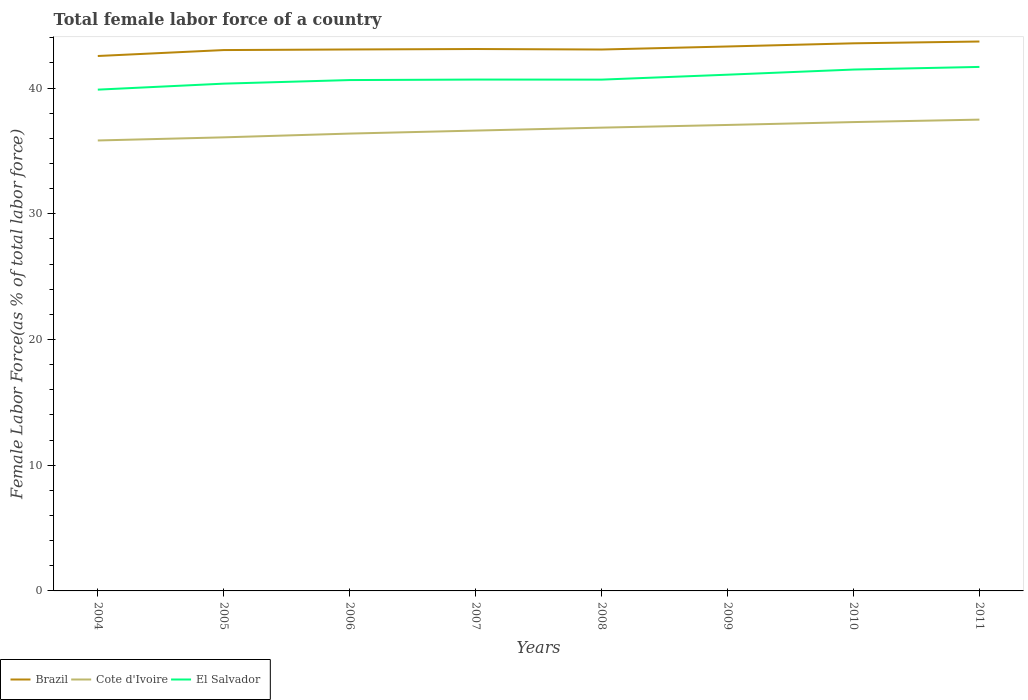How many different coloured lines are there?
Give a very brief answer. 3. Is the number of lines equal to the number of legend labels?
Keep it short and to the point. Yes. Across all years, what is the maximum percentage of female labor force in El Salvador?
Provide a short and direct response. 39.87. In which year was the percentage of female labor force in Cote d'Ivoire maximum?
Keep it short and to the point. 2004. What is the total percentage of female labor force in Cote d'Ivoire in the graph?
Keep it short and to the point. -0.24. What is the difference between the highest and the second highest percentage of female labor force in El Salvador?
Keep it short and to the point. 1.81. Is the percentage of female labor force in Brazil strictly greater than the percentage of female labor force in Cote d'Ivoire over the years?
Provide a succinct answer. No. How many lines are there?
Keep it short and to the point. 3. How many years are there in the graph?
Provide a short and direct response. 8. What is the difference between two consecutive major ticks on the Y-axis?
Provide a short and direct response. 10. Are the values on the major ticks of Y-axis written in scientific E-notation?
Your response must be concise. No. Does the graph contain grids?
Provide a short and direct response. No. Where does the legend appear in the graph?
Keep it short and to the point. Bottom left. What is the title of the graph?
Provide a short and direct response. Total female labor force of a country. Does "Congo (Democratic)" appear as one of the legend labels in the graph?
Provide a succinct answer. No. What is the label or title of the X-axis?
Offer a very short reply. Years. What is the label or title of the Y-axis?
Your answer should be compact. Female Labor Force(as % of total labor force). What is the Female Labor Force(as % of total labor force) in Brazil in 2004?
Your answer should be compact. 42.55. What is the Female Labor Force(as % of total labor force) in Cote d'Ivoire in 2004?
Give a very brief answer. 35.83. What is the Female Labor Force(as % of total labor force) of El Salvador in 2004?
Make the answer very short. 39.87. What is the Female Labor Force(as % of total labor force) in Brazil in 2005?
Offer a very short reply. 43.02. What is the Female Labor Force(as % of total labor force) in Cote d'Ivoire in 2005?
Your answer should be very brief. 36.08. What is the Female Labor Force(as % of total labor force) in El Salvador in 2005?
Offer a very short reply. 40.35. What is the Female Labor Force(as % of total labor force) of Brazil in 2006?
Your answer should be very brief. 43.07. What is the Female Labor Force(as % of total labor force) of Cote d'Ivoire in 2006?
Your answer should be compact. 36.38. What is the Female Labor Force(as % of total labor force) in El Salvador in 2006?
Your answer should be compact. 40.63. What is the Female Labor Force(as % of total labor force) of Brazil in 2007?
Your response must be concise. 43.1. What is the Female Labor Force(as % of total labor force) in Cote d'Ivoire in 2007?
Provide a succinct answer. 36.61. What is the Female Labor Force(as % of total labor force) of El Salvador in 2007?
Provide a short and direct response. 40.67. What is the Female Labor Force(as % of total labor force) of Brazil in 2008?
Your response must be concise. 43.06. What is the Female Labor Force(as % of total labor force) of Cote d'Ivoire in 2008?
Provide a short and direct response. 36.85. What is the Female Labor Force(as % of total labor force) in El Salvador in 2008?
Offer a very short reply. 40.67. What is the Female Labor Force(as % of total labor force) of Brazil in 2009?
Offer a very short reply. 43.3. What is the Female Labor Force(as % of total labor force) in Cote d'Ivoire in 2009?
Make the answer very short. 37.06. What is the Female Labor Force(as % of total labor force) in El Salvador in 2009?
Your response must be concise. 41.06. What is the Female Labor Force(as % of total labor force) of Brazil in 2010?
Ensure brevity in your answer.  43.56. What is the Female Labor Force(as % of total labor force) of Cote d'Ivoire in 2010?
Provide a short and direct response. 37.29. What is the Female Labor Force(as % of total labor force) in El Salvador in 2010?
Offer a very short reply. 41.47. What is the Female Labor Force(as % of total labor force) of Brazil in 2011?
Provide a succinct answer. 43.7. What is the Female Labor Force(as % of total labor force) in Cote d'Ivoire in 2011?
Ensure brevity in your answer.  37.49. What is the Female Labor Force(as % of total labor force) in El Salvador in 2011?
Offer a terse response. 41.68. Across all years, what is the maximum Female Labor Force(as % of total labor force) of Brazil?
Ensure brevity in your answer.  43.7. Across all years, what is the maximum Female Labor Force(as % of total labor force) in Cote d'Ivoire?
Make the answer very short. 37.49. Across all years, what is the maximum Female Labor Force(as % of total labor force) of El Salvador?
Your response must be concise. 41.68. Across all years, what is the minimum Female Labor Force(as % of total labor force) in Brazil?
Provide a succinct answer. 42.55. Across all years, what is the minimum Female Labor Force(as % of total labor force) of Cote d'Ivoire?
Keep it short and to the point. 35.83. Across all years, what is the minimum Female Labor Force(as % of total labor force) of El Salvador?
Offer a very short reply. 39.87. What is the total Female Labor Force(as % of total labor force) of Brazil in the graph?
Your answer should be very brief. 345.35. What is the total Female Labor Force(as % of total labor force) in Cote d'Ivoire in the graph?
Keep it short and to the point. 293.58. What is the total Female Labor Force(as % of total labor force) in El Salvador in the graph?
Offer a terse response. 326.4. What is the difference between the Female Labor Force(as % of total labor force) in Brazil in 2004 and that in 2005?
Your answer should be compact. -0.47. What is the difference between the Female Labor Force(as % of total labor force) in Cote d'Ivoire in 2004 and that in 2005?
Your response must be concise. -0.25. What is the difference between the Female Labor Force(as % of total labor force) of El Salvador in 2004 and that in 2005?
Give a very brief answer. -0.48. What is the difference between the Female Labor Force(as % of total labor force) in Brazil in 2004 and that in 2006?
Provide a succinct answer. -0.52. What is the difference between the Female Labor Force(as % of total labor force) of Cote d'Ivoire in 2004 and that in 2006?
Provide a succinct answer. -0.55. What is the difference between the Female Labor Force(as % of total labor force) of El Salvador in 2004 and that in 2006?
Your answer should be compact. -0.76. What is the difference between the Female Labor Force(as % of total labor force) of Brazil in 2004 and that in 2007?
Your answer should be very brief. -0.56. What is the difference between the Female Labor Force(as % of total labor force) of Cote d'Ivoire in 2004 and that in 2007?
Provide a succinct answer. -0.79. What is the difference between the Female Labor Force(as % of total labor force) of El Salvador in 2004 and that in 2007?
Your answer should be very brief. -0.8. What is the difference between the Female Labor Force(as % of total labor force) in Brazil in 2004 and that in 2008?
Offer a very short reply. -0.52. What is the difference between the Female Labor Force(as % of total labor force) of Cote d'Ivoire in 2004 and that in 2008?
Offer a terse response. -1.02. What is the difference between the Female Labor Force(as % of total labor force) of El Salvador in 2004 and that in 2008?
Give a very brief answer. -0.8. What is the difference between the Female Labor Force(as % of total labor force) in Brazil in 2004 and that in 2009?
Keep it short and to the point. -0.76. What is the difference between the Female Labor Force(as % of total labor force) of Cote d'Ivoire in 2004 and that in 2009?
Your answer should be compact. -1.23. What is the difference between the Female Labor Force(as % of total labor force) in El Salvador in 2004 and that in 2009?
Provide a short and direct response. -1.19. What is the difference between the Female Labor Force(as % of total labor force) of Brazil in 2004 and that in 2010?
Offer a terse response. -1.01. What is the difference between the Female Labor Force(as % of total labor force) of Cote d'Ivoire in 2004 and that in 2010?
Ensure brevity in your answer.  -1.46. What is the difference between the Female Labor Force(as % of total labor force) of El Salvador in 2004 and that in 2010?
Give a very brief answer. -1.6. What is the difference between the Female Labor Force(as % of total labor force) in Brazil in 2004 and that in 2011?
Offer a terse response. -1.15. What is the difference between the Female Labor Force(as % of total labor force) of Cote d'Ivoire in 2004 and that in 2011?
Provide a short and direct response. -1.66. What is the difference between the Female Labor Force(as % of total labor force) in El Salvador in 2004 and that in 2011?
Provide a succinct answer. -1.81. What is the difference between the Female Labor Force(as % of total labor force) of Brazil in 2005 and that in 2006?
Offer a very short reply. -0.05. What is the difference between the Female Labor Force(as % of total labor force) in Cote d'Ivoire in 2005 and that in 2006?
Keep it short and to the point. -0.3. What is the difference between the Female Labor Force(as % of total labor force) in El Salvador in 2005 and that in 2006?
Provide a short and direct response. -0.29. What is the difference between the Female Labor Force(as % of total labor force) in Brazil in 2005 and that in 2007?
Ensure brevity in your answer.  -0.08. What is the difference between the Female Labor Force(as % of total labor force) in Cote d'Ivoire in 2005 and that in 2007?
Make the answer very short. -0.54. What is the difference between the Female Labor Force(as % of total labor force) of El Salvador in 2005 and that in 2007?
Keep it short and to the point. -0.32. What is the difference between the Female Labor Force(as % of total labor force) of Brazil in 2005 and that in 2008?
Provide a short and direct response. -0.04. What is the difference between the Female Labor Force(as % of total labor force) of Cote d'Ivoire in 2005 and that in 2008?
Your response must be concise. -0.77. What is the difference between the Female Labor Force(as % of total labor force) in El Salvador in 2005 and that in 2008?
Provide a short and direct response. -0.32. What is the difference between the Female Labor Force(as % of total labor force) in Brazil in 2005 and that in 2009?
Offer a terse response. -0.28. What is the difference between the Female Labor Force(as % of total labor force) of Cote d'Ivoire in 2005 and that in 2009?
Give a very brief answer. -0.99. What is the difference between the Female Labor Force(as % of total labor force) in El Salvador in 2005 and that in 2009?
Your answer should be compact. -0.71. What is the difference between the Female Labor Force(as % of total labor force) in Brazil in 2005 and that in 2010?
Your response must be concise. -0.54. What is the difference between the Female Labor Force(as % of total labor force) of Cote d'Ivoire in 2005 and that in 2010?
Offer a very short reply. -1.21. What is the difference between the Female Labor Force(as % of total labor force) of El Salvador in 2005 and that in 2010?
Offer a terse response. -1.12. What is the difference between the Female Labor Force(as % of total labor force) of Brazil in 2005 and that in 2011?
Your answer should be compact. -0.68. What is the difference between the Female Labor Force(as % of total labor force) of Cote d'Ivoire in 2005 and that in 2011?
Your answer should be compact. -1.41. What is the difference between the Female Labor Force(as % of total labor force) of El Salvador in 2005 and that in 2011?
Ensure brevity in your answer.  -1.33. What is the difference between the Female Labor Force(as % of total labor force) in Brazil in 2006 and that in 2007?
Your answer should be compact. -0.04. What is the difference between the Female Labor Force(as % of total labor force) of Cote d'Ivoire in 2006 and that in 2007?
Give a very brief answer. -0.24. What is the difference between the Female Labor Force(as % of total labor force) in El Salvador in 2006 and that in 2007?
Your response must be concise. -0.04. What is the difference between the Female Labor Force(as % of total labor force) in Brazil in 2006 and that in 2008?
Make the answer very short. 0. What is the difference between the Female Labor Force(as % of total labor force) of Cote d'Ivoire in 2006 and that in 2008?
Ensure brevity in your answer.  -0.47. What is the difference between the Female Labor Force(as % of total labor force) in El Salvador in 2006 and that in 2008?
Provide a short and direct response. -0.04. What is the difference between the Female Labor Force(as % of total labor force) of Brazil in 2006 and that in 2009?
Your answer should be compact. -0.24. What is the difference between the Female Labor Force(as % of total labor force) in Cote d'Ivoire in 2006 and that in 2009?
Your answer should be compact. -0.69. What is the difference between the Female Labor Force(as % of total labor force) of El Salvador in 2006 and that in 2009?
Your response must be concise. -0.43. What is the difference between the Female Labor Force(as % of total labor force) of Brazil in 2006 and that in 2010?
Give a very brief answer. -0.49. What is the difference between the Female Labor Force(as % of total labor force) in Cote d'Ivoire in 2006 and that in 2010?
Make the answer very short. -0.91. What is the difference between the Female Labor Force(as % of total labor force) of El Salvador in 2006 and that in 2010?
Keep it short and to the point. -0.84. What is the difference between the Female Labor Force(as % of total labor force) in Brazil in 2006 and that in 2011?
Provide a short and direct response. -0.63. What is the difference between the Female Labor Force(as % of total labor force) of Cote d'Ivoire in 2006 and that in 2011?
Provide a short and direct response. -1.11. What is the difference between the Female Labor Force(as % of total labor force) of El Salvador in 2006 and that in 2011?
Your answer should be compact. -1.05. What is the difference between the Female Labor Force(as % of total labor force) in Brazil in 2007 and that in 2008?
Make the answer very short. 0.04. What is the difference between the Female Labor Force(as % of total labor force) in Cote d'Ivoire in 2007 and that in 2008?
Your answer should be compact. -0.23. What is the difference between the Female Labor Force(as % of total labor force) of El Salvador in 2007 and that in 2008?
Make the answer very short. 0. What is the difference between the Female Labor Force(as % of total labor force) of Brazil in 2007 and that in 2009?
Your answer should be compact. -0.2. What is the difference between the Female Labor Force(as % of total labor force) of Cote d'Ivoire in 2007 and that in 2009?
Keep it short and to the point. -0.45. What is the difference between the Female Labor Force(as % of total labor force) in El Salvador in 2007 and that in 2009?
Give a very brief answer. -0.39. What is the difference between the Female Labor Force(as % of total labor force) of Brazil in 2007 and that in 2010?
Offer a terse response. -0.45. What is the difference between the Female Labor Force(as % of total labor force) in Cote d'Ivoire in 2007 and that in 2010?
Provide a succinct answer. -0.68. What is the difference between the Female Labor Force(as % of total labor force) in El Salvador in 2007 and that in 2010?
Make the answer very short. -0.8. What is the difference between the Female Labor Force(as % of total labor force) in Brazil in 2007 and that in 2011?
Provide a short and direct response. -0.6. What is the difference between the Female Labor Force(as % of total labor force) of Cote d'Ivoire in 2007 and that in 2011?
Provide a short and direct response. -0.87. What is the difference between the Female Labor Force(as % of total labor force) of El Salvador in 2007 and that in 2011?
Give a very brief answer. -1.01. What is the difference between the Female Labor Force(as % of total labor force) of Brazil in 2008 and that in 2009?
Keep it short and to the point. -0.24. What is the difference between the Female Labor Force(as % of total labor force) in Cote d'Ivoire in 2008 and that in 2009?
Ensure brevity in your answer.  -0.21. What is the difference between the Female Labor Force(as % of total labor force) in El Salvador in 2008 and that in 2009?
Provide a succinct answer. -0.39. What is the difference between the Female Labor Force(as % of total labor force) in Brazil in 2008 and that in 2010?
Provide a short and direct response. -0.49. What is the difference between the Female Labor Force(as % of total labor force) in Cote d'Ivoire in 2008 and that in 2010?
Keep it short and to the point. -0.44. What is the difference between the Female Labor Force(as % of total labor force) of El Salvador in 2008 and that in 2010?
Keep it short and to the point. -0.8. What is the difference between the Female Labor Force(as % of total labor force) in Brazil in 2008 and that in 2011?
Ensure brevity in your answer.  -0.64. What is the difference between the Female Labor Force(as % of total labor force) of Cote d'Ivoire in 2008 and that in 2011?
Your response must be concise. -0.64. What is the difference between the Female Labor Force(as % of total labor force) of El Salvador in 2008 and that in 2011?
Give a very brief answer. -1.01. What is the difference between the Female Labor Force(as % of total labor force) of Brazil in 2009 and that in 2010?
Ensure brevity in your answer.  -0.25. What is the difference between the Female Labor Force(as % of total labor force) in Cote d'Ivoire in 2009 and that in 2010?
Provide a succinct answer. -0.23. What is the difference between the Female Labor Force(as % of total labor force) in El Salvador in 2009 and that in 2010?
Your answer should be very brief. -0.41. What is the difference between the Female Labor Force(as % of total labor force) of Brazil in 2009 and that in 2011?
Provide a succinct answer. -0.39. What is the difference between the Female Labor Force(as % of total labor force) in Cote d'Ivoire in 2009 and that in 2011?
Provide a succinct answer. -0.42. What is the difference between the Female Labor Force(as % of total labor force) in El Salvador in 2009 and that in 2011?
Keep it short and to the point. -0.62. What is the difference between the Female Labor Force(as % of total labor force) of Brazil in 2010 and that in 2011?
Provide a succinct answer. -0.14. What is the difference between the Female Labor Force(as % of total labor force) in Cote d'Ivoire in 2010 and that in 2011?
Provide a short and direct response. -0.2. What is the difference between the Female Labor Force(as % of total labor force) of El Salvador in 2010 and that in 2011?
Ensure brevity in your answer.  -0.21. What is the difference between the Female Labor Force(as % of total labor force) of Brazil in 2004 and the Female Labor Force(as % of total labor force) of Cote d'Ivoire in 2005?
Your answer should be compact. 6.47. What is the difference between the Female Labor Force(as % of total labor force) in Brazil in 2004 and the Female Labor Force(as % of total labor force) in El Salvador in 2005?
Provide a short and direct response. 2.2. What is the difference between the Female Labor Force(as % of total labor force) in Cote d'Ivoire in 2004 and the Female Labor Force(as % of total labor force) in El Salvador in 2005?
Offer a very short reply. -4.52. What is the difference between the Female Labor Force(as % of total labor force) of Brazil in 2004 and the Female Labor Force(as % of total labor force) of Cote d'Ivoire in 2006?
Give a very brief answer. 6.17. What is the difference between the Female Labor Force(as % of total labor force) of Brazil in 2004 and the Female Labor Force(as % of total labor force) of El Salvador in 2006?
Offer a very short reply. 1.91. What is the difference between the Female Labor Force(as % of total labor force) in Cote d'Ivoire in 2004 and the Female Labor Force(as % of total labor force) in El Salvador in 2006?
Your answer should be compact. -4.8. What is the difference between the Female Labor Force(as % of total labor force) of Brazil in 2004 and the Female Labor Force(as % of total labor force) of Cote d'Ivoire in 2007?
Ensure brevity in your answer.  5.93. What is the difference between the Female Labor Force(as % of total labor force) of Brazil in 2004 and the Female Labor Force(as % of total labor force) of El Salvador in 2007?
Your answer should be compact. 1.87. What is the difference between the Female Labor Force(as % of total labor force) in Cote d'Ivoire in 2004 and the Female Labor Force(as % of total labor force) in El Salvador in 2007?
Make the answer very short. -4.84. What is the difference between the Female Labor Force(as % of total labor force) of Brazil in 2004 and the Female Labor Force(as % of total labor force) of Cote d'Ivoire in 2008?
Provide a succinct answer. 5.7. What is the difference between the Female Labor Force(as % of total labor force) of Brazil in 2004 and the Female Labor Force(as % of total labor force) of El Salvador in 2008?
Give a very brief answer. 1.88. What is the difference between the Female Labor Force(as % of total labor force) of Cote d'Ivoire in 2004 and the Female Labor Force(as % of total labor force) of El Salvador in 2008?
Offer a very short reply. -4.84. What is the difference between the Female Labor Force(as % of total labor force) of Brazil in 2004 and the Female Labor Force(as % of total labor force) of Cote d'Ivoire in 2009?
Your answer should be very brief. 5.48. What is the difference between the Female Labor Force(as % of total labor force) in Brazil in 2004 and the Female Labor Force(as % of total labor force) in El Salvador in 2009?
Your answer should be very brief. 1.49. What is the difference between the Female Labor Force(as % of total labor force) in Cote d'Ivoire in 2004 and the Female Labor Force(as % of total labor force) in El Salvador in 2009?
Keep it short and to the point. -5.23. What is the difference between the Female Labor Force(as % of total labor force) in Brazil in 2004 and the Female Labor Force(as % of total labor force) in Cote d'Ivoire in 2010?
Keep it short and to the point. 5.26. What is the difference between the Female Labor Force(as % of total labor force) in Brazil in 2004 and the Female Labor Force(as % of total labor force) in El Salvador in 2010?
Your answer should be compact. 1.08. What is the difference between the Female Labor Force(as % of total labor force) in Cote d'Ivoire in 2004 and the Female Labor Force(as % of total labor force) in El Salvador in 2010?
Make the answer very short. -5.64. What is the difference between the Female Labor Force(as % of total labor force) in Brazil in 2004 and the Female Labor Force(as % of total labor force) in Cote d'Ivoire in 2011?
Your response must be concise. 5.06. What is the difference between the Female Labor Force(as % of total labor force) of Brazil in 2004 and the Female Labor Force(as % of total labor force) of El Salvador in 2011?
Make the answer very short. 0.87. What is the difference between the Female Labor Force(as % of total labor force) in Cote d'Ivoire in 2004 and the Female Labor Force(as % of total labor force) in El Salvador in 2011?
Keep it short and to the point. -5.85. What is the difference between the Female Labor Force(as % of total labor force) in Brazil in 2005 and the Female Labor Force(as % of total labor force) in Cote d'Ivoire in 2006?
Keep it short and to the point. 6.64. What is the difference between the Female Labor Force(as % of total labor force) of Brazil in 2005 and the Female Labor Force(as % of total labor force) of El Salvador in 2006?
Offer a terse response. 2.39. What is the difference between the Female Labor Force(as % of total labor force) in Cote d'Ivoire in 2005 and the Female Labor Force(as % of total labor force) in El Salvador in 2006?
Give a very brief answer. -4.56. What is the difference between the Female Labor Force(as % of total labor force) in Brazil in 2005 and the Female Labor Force(as % of total labor force) in Cote d'Ivoire in 2007?
Offer a terse response. 6.4. What is the difference between the Female Labor Force(as % of total labor force) of Brazil in 2005 and the Female Labor Force(as % of total labor force) of El Salvador in 2007?
Ensure brevity in your answer.  2.35. What is the difference between the Female Labor Force(as % of total labor force) of Cote d'Ivoire in 2005 and the Female Labor Force(as % of total labor force) of El Salvador in 2007?
Provide a short and direct response. -4.6. What is the difference between the Female Labor Force(as % of total labor force) of Brazil in 2005 and the Female Labor Force(as % of total labor force) of Cote d'Ivoire in 2008?
Your answer should be compact. 6.17. What is the difference between the Female Labor Force(as % of total labor force) of Brazil in 2005 and the Female Labor Force(as % of total labor force) of El Salvador in 2008?
Make the answer very short. 2.35. What is the difference between the Female Labor Force(as % of total labor force) of Cote d'Ivoire in 2005 and the Female Labor Force(as % of total labor force) of El Salvador in 2008?
Give a very brief answer. -4.59. What is the difference between the Female Labor Force(as % of total labor force) in Brazil in 2005 and the Female Labor Force(as % of total labor force) in Cote d'Ivoire in 2009?
Offer a terse response. 5.96. What is the difference between the Female Labor Force(as % of total labor force) in Brazil in 2005 and the Female Labor Force(as % of total labor force) in El Salvador in 2009?
Make the answer very short. 1.96. What is the difference between the Female Labor Force(as % of total labor force) in Cote d'Ivoire in 2005 and the Female Labor Force(as % of total labor force) in El Salvador in 2009?
Your response must be concise. -4.98. What is the difference between the Female Labor Force(as % of total labor force) of Brazil in 2005 and the Female Labor Force(as % of total labor force) of Cote d'Ivoire in 2010?
Your answer should be compact. 5.73. What is the difference between the Female Labor Force(as % of total labor force) in Brazil in 2005 and the Female Labor Force(as % of total labor force) in El Salvador in 2010?
Provide a succinct answer. 1.55. What is the difference between the Female Labor Force(as % of total labor force) in Cote d'Ivoire in 2005 and the Female Labor Force(as % of total labor force) in El Salvador in 2010?
Keep it short and to the point. -5.39. What is the difference between the Female Labor Force(as % of total labor force) of Brazil in 2005 and the Female Labor Force(as % of total labor force) of Cote d'Ivoire in 2011?
Your answer should be very brief. 5.53. What is the difference between the Female Labor Force(as % of total labor force) of Brazil in 2005 and the Female Labor Force(as % of total labor force) of El Salvador in 2011?
Provide a short and direct response. 1.34. What is the difference between the Female Labor Force(as % of total labor force) in Cote d'Ivoire in 2005 and the Female Labor Force(as % of total labor force) in El Salvador in 2011?
Provide a short and direct response. -5.6. What is the difference between the Female Labor Force(as % of total labor force) in Brazil in 2006 and the Female Labor Force(as % of total labor force) in Cote d'Ivoire in 2007?
Your answer should be very brief. 6.45. What is the difference between the Female Labor Force(as % of total labor force) of Brazil in 2006 and the Female Labor Force(as % of total labor force) of El Salvador in 2007?
Your answer should be compact. 2.39. What is the difference between the Female Labor Force(as % of total labor force) in Cote d'Ivoire in 2006 and the Female Labor Force(as % of total labor force) in El Salvador in 2007?
Offer a very short reply. -4.3. What is the difference between the Female Labor Force(as % of total labor force) of Brazil in 2006 and the Female Labor Force(as % of total labor force) of Cote d'Ivoire in 2008?
Your response must be concise. 6.22. What is the difference between the Female Labor Force(as % of total labor force) in Brazil in 2006 and the Female Labor Force(as % of total labor force) in El Salvador in 2008?
Provide a short and direct response. 2.4. What is the difference between the Female Labor Force(as % of total labor force) of Cote d'Ivoire in 2006 and the Female Labor Force(as % of total labor force) of El Salvador in 2008?
Give a very brief answer. -4.29. What is the difference between the Female Labor Force(as % of total labor force) of Brazil in 2006 and the Female Labor Force(as % of total labor force) of Cote d'Ivoire in 2009?
Offer a very short reply. 6. What is the difference between the Female Labor Force(as % of total labor force) in Brazil in 2006 and the Female Labor Force(as % of total labor force) in El Salvador in 2009?
Your answer should be very brief. 2.01. What is the difference between the Female Labor Force(as % of total labor force) of Cote d'Ivoire in 2006 and the Female Labor Force(as % of total labor force) of El Salvador in 2009?
Keep it short and to the point. -4.68. What is the difference between the Female Labor Force(as % of total labor force) of Brazil in 2006 and the Female Labor Force(as % of total labor force) of Cote d'Ivoire in 2010?
Make the answer very short. 5.78. What is the difference between the Female Labor Force(as % of total labor force) of Brazil in 2006 and the Female Labor Force(as % of total labor force) of El Salvador in 2010?
Ensure brevity in your answer.  1.6. What is the difference between the Female Labor Force(as % of total labor force) of Cote d'Ivoire in 2006 and the Female Labor Force(as % of total labor force) of El Salvador in 2010?
Offer a very short reply. -5.09. What is the difference between the Female Labor Force(as % of total labor force) of Brazil in 2006 and the Female Labor Force(as % of total labor force) of Cote d'Ivoire in 2011?
Offer a terse response. 5.58. What is the difference between the Female Labor Force(as % of total labor force) of Brazil in 2006 and the Female Labor Force(as % of total labor force) of El Salvador in 2011?
Your answer should be compact. 1.39. What is the difference between the Female Labor Force(as % of total labor force) of Cote d'Ivoire in 2006 and the Female Labor Force(as % of total labor force) of El Salvador in 2011?
Make the answer very short. -5.3. What is the difference between the Female Labor Force(as % of total labor force) of Brazil in 2007 and the Female Labor Force(as % of total labor force) of Cote d'Ivoire in 2008?
Give a very brief answer. 6.25. What is the difference between the Female Labor Force(as % of total labor force) in Brazil in 2007 and the Female Labor Force(as % of total labor force) in El Salvador in 2008?
Make the answer very short. 2.43. What is the difference between the Female Labor Force(as % of total labor force) in Cote d'Ivoire in 2007 and the Female Labor Force(as % of total labor force) in El Salvador in 2008?
Ensure brevity in your answer.  -4.05. What is the difference between the Female Labor Force(as % of total labor force) in Brazil in 2007 and the Female Labor Force(as % of total labor force) in Cote d'Ivoire in 2009?
Your response must be concise. 6.04. What is the difference between the Female Labor Force(as % of total labor force) in Brazil in 2007 and the Female Labor Force(as % of total labor force) in El Salvador in 2009?
Offer a very short reply. 2.04. What is the difference between the Female Labor Force(as % of total labor force) of Cote d'Ivoire in 2007 and the Female Labor Force(as % of total labor force) of El Salvador in 2009?
Your response must be concise. -4.45. What is the difference between the Female Labor Force(as % of total labor force) in Brazil in 2007 and the Female Labor Force(as % of total labor force) in Cote d'Ivoire in 2010?
Offer a very short reply. 5.81. What is the difference between the Female Labor Force(as % of total labor force) in Brazil in 2007 and the Female Labor Force(as % of total labor force) in El Salvador in 2010?
Ensure brevity in your answer.  1.63. What is the difference between the Female Labor Force(as % of total labor force) in Cote d'Ivoire in 2007 and the Female Labor Force(as % of total labor force) in El Salvador in 2010?
Provide a short and direct response. -4.85. What is the difference between the Female Labor Force(as % of total labor force) in Brazil in 2007 and the Female Labor Force(as % of total labor force) in Cote d'Ivoire in 2011?
Offer a very short reply. 5.62. What is the difference between the Female Labor Force(as % of total labor force) in Brazil in 2007 and the Female Labor Force(as % of total labor force) in El Salvador in 2011?
Give a very brief answer. 1.42. What is the difference between the Female Labor Force(as % of total labor force) of Cote d'Ivoire in 2007 and the Female Labor Force(as % of total labor force) of El Salvador in 2011?
Make the answer very short. -5.06. What is the difference between the Female Labor Force(as % of total labor force) in Brazil in 2008 and the Female Labor Force(as % of total labor force) in Cote d'Ivoire in 2009?
Ensure brevity in your answer.  6. What is the difference between the Female Labor Force(as % of total labor force) in Brazil in 2008 and the Female Labor Force(as % of total labor force) in El Salvador in 2009?
Offer a very short reply. 2. What is the difference between the Female Labor Force(as % of total labor force) of Cote d'Ivoire in 2008 and the Female Labor Force(as % of total labor force) of El Salvador in 2009?
Your answer should be compact. -4.21. What is the difference between the Female Labor Force(as % of total labor force) of Brazil in 2008 and the Female Labor Force(as % of total labor force) of Cote d'Ivoire in 2010?
Ensure brevity in your answer.  5.77. What is the difference between the Female Labor Force(as % of total labor force) of Brazil in 2008 and the Female Labor Force(as % of total labor force) of El Salvador in 2010?
Keep it short and to the point. 1.59. What is the difference between the Female Labor Force(as % of total labor force) of Cote d'Ivoire in 2008 and the Female Labor Force(as % of total labor force) of El Salvador in 2010?
Provide a short and direct response. -4.62. What is the difference between the Female Labor Force(as % of total labor force) in Brazil in 2008 and the Female Labor Force(as % of total labor force) in Cote d'Ivoire in 2011?
Ensure brevity in your answer.  5.58. What is the difference between the Female Labor Force(as % of total labor force) in Brazil in 2008 and the Female Labor Force(as % of total labor force) in El Salvador in 2011?
Ensure brevity in your answer.  1.38. What is the difference between the Female Labor Force(as % of total labor force) of Cote d'Ivoire in 2008 and the Female Labor Force(as % of total labor force) of El Salvador in 2011?
Your response must be concise. -4.83. What is the difference between the Female Labor Force(as % of total labor force) in Brazil in 2009 and the Female Labor Force(as % of total labor force) in Cote d'Ivoire in 2010?
Your answer should be very brief. 6.01. What is the difference between the Female Labor Force(as % of total labor force) of Brazil in 2009 and the Female Labor Force(as % of total labor force) of El Salvador in 2010?
Your answer should be compact. 1.83. What is the difference between the Female Labor Force(as % of total labor force) of Cote d'Ivoire in 2009 and the Female Labor Force(as % of total labor force) of El Salvador in 2010?
Provide a succinct answer. -4.41. What is the difference between the Female Labor Force(as % of total labor force) of Brazil in 2009 and the Female Labor Force(as % of total labor force) of Cote d'Ivoire in 2011?
Make the answer very short. 5.82. What is the difference between the Female Labor Force(as % of total labor force) in Brazil in 2009 and the Female Labor Force(as % of total labor force) in El Salvador in 2011?
Ensure brevity in your answer.  1.63. What is the difference between the Female Labor Force(as % of total labor force) of Cote d'Ivoire in 2009 and the Female Labor Force(as % of total labor force) of El Salvador in 2011?
Give a very brief answer. -4.62. What is the difference between the Female Labor Force(as % of total labor force) in Brazil in 2010 and the Female Labor Force(as % of total labor force) in Cote d'Ivoire in 2011?
Offer a very short reply. 6.07. What is the difference between the Female Labor Force(as % of total labor force) in Brazil in 2010 and the Female Labor Force(as % of total labor force) in El Salvador in 2011?
Your answer should be very brief. 1.88. What is the difference between the Female Labor Force(as % of total labor force) in Cote d'Ivoire in 2010 and the Female Labor Force(as % of total labor force) in El Salvador in 2011?
Make the answer very short. -4.39. What is the average Female Labor Force(as % of total labor force) in Brazil per year?
Keep it short and to the point. 43.17. What is the average Female Labor Force(as % of total labor force) in Cote d'Ivoire per year?
Ensure brevity in your answer.  36.7. What is the average Female Labor Force(as % of total labor force) of El Salvador per year?
Ensure brevity in your answer.  40.8. In the year 2004, what is the difference between the Female Labor Force(as % of total labor force) in Brazil and Female Labor Force(as % of total labor force) in Cote d'Ivoire?
Provide a succinct answer. 6.72. In the year 2004, what is the difference between the Female Labor Force(as % of total labor force) of Brazil and Female Labor Force(as % of total labor force) of El Salvador?
Offer a very short reply. 2.68. In the year 2004, what is the difference between the Female Labor Force(as % of total labor force) of Cote d'Ivoire and Female Labor Force(as % of total labor force) of El Salvador?
Your answer should be compact. -4.04. In the year 2005, what is the difference between the Female Labor Force(as % of total labor force) in Brazil and Female Labor Force(as % of total labor force) in Cote d'Ivoire?
Your answer should be very brief. 6.94. In the year 2005, what is the difference between the Female Labor Force(as % of total labor force) of Brazil and Female Labor Force(as % of total labor force) of El Salvador?
Your response must be concise. 2.67. In the year 2005, what is the difference between the Female Labor Force(as % of total labor force) in Cote d'Ivoire and Female Labor Force(as % of total labor force) in El Salvador?
Make the answer very short. -4.27. In the year 2006, what is the difference between the Female Labor Force(as % of total labor force) in Brazil and Female Labor Force(as % of total labor force) in Cote d'Ivoire?
Offer a terse response. 6.69. In the year 2006, what is the difference between the Female Labor Force(as % of total labor force) of Brazil and Female Labor Force(as % of total labor force) of El Salvador?
Ensure brevity in your answer.  2.43. In the year 2006, what is the difference between the Female Labor Force(as % of total labor force) in Cote d'Ivoire and Female Labor Force(as % of total labor force) in El Salvador?
Offer a very short reply. -4.26. In the year 2007, what is the difference between the Female Labor Force(as % of total labor force) of Brazil and Female Labor Force(as % of total labor force) of Cote d'Ivoire?
Keep it short and to the point. 6.49. In the year 2007, what is the difference between the Female Labor Force(as % of total labor force) of Brazil and Female Labor Force(as % of total labor force) of El Salvador?
Provide a short and direct response. 2.43. In the year 2007, what is the difference between the Female Labor Force(as % of total labor force) of Cote d'Ivoire and Female Labor Force(as % of total labor force) of El Salvador?
Offer a very short reply. -4.06. In the year 2008, what is the difference between the Female Labor Force(as % of total labor force) of Brazil and Female Labor Force(as % of total labor force) of Cote d'Ivoire?
Give a very brief answer. 6.21. In the year 2008, what is the difference between the Female Labor Force(as % of total labor force) in Brazil and Female Labor Force(as % of total labor force) in El Salvador?
Keep it short and to the point. 2.39. In the year 2008, what is the difference between the Female Labor Force(as % of total labor force) of Cote d'Ivoire and Female Labor Force(as % of total labor force) of El Salvador?
Your answer should be compact. -3.82. In the year 2009, what is the difference between the Female Labor Force(as % of total labor force) in Brazil and Female Labor Force(as % of total labor force) in Cote d'Ivoire?
Give a very brief answer. 6.24. In the year 2009, what is the difference between the Female Labor Force(as % of total labor force) in Brazil and Female Labor Force(as % of total labor force) in El Salvador?
Offer a very short reply. 2.24. In the year 2009, what is the difference between the Female Labor Force(as % of total labor force) in Cote d'Ivoire and Female Labor Force(as % of total labor force) in El Salvador?
Your answer should be very brief. -4. In the year 2010, what is the difference between the Female Labor Force(as % of total labor force) of Brazil and Female Labor Force(as % of total labor force) of Cote d'Ivoire?
Your answer should be compact. 6.27. In the year 2010, what is the difference between the Female Labor Force(as % of total labor force) in Brazil and Female Labor Force(as % of total labor force) in El Salvador?
Provide a short and direct response. 2.09. In the year 2010, what is the difference between the Female Labor Force(as % of total labor force) of Cote d'Ivoire and Female Labor Force(as % of total labor force) of El Salvador?
Provide a succinct answer. -4.18. In the year 2011, what is the difference between the Female Labor Force(as % of total labor force) of Brazil and Female Labor Force(as % of total labor force) of Cote d'Ivoire?
Offer a very short reply. 6.21. In the year 2011, what is the difference between the Female Labor Force(as % of total labor force) in Brazil and Female Labor Force(as % of total labor force) in El Salvador?
Offer a terse response. 2.02. In the year 2011, what is the difference between the Female Labor Force(as % of total labor force) in Cote d'Ivoire and Female Labor Force(as % of total labor force) in El Salvador?
Offer a terse response. -4.19. What is the ratio of the Female Labor Force(as % of total labor force) of Brazil in 2004 to that in 2005?
Your answer should be very brief. 0.99. What is the ratio of the Female Labor Force(as % of total labor force) in Cote d'Ivoire in 2004 to that in 2005?
Offer a terse response. 0.99. What is the ratio of the Female Labor Force(as % of total labor force) of Brazil in 2004 to that in 2006?
Offer a terse response. 0.99. What is the ratio of the Female Labor Force(as % of total labor force) in Cote d'Ivoire in 2004 to that in 2006?
Offer a very short reply. 0.98. What is the ratio of the Female Labor Force(as % of total labor force) of El Salvador in 2004 to that in 2006?
Make the answer very short. 0.98. What is the ratio of the Female Labor Force(as % of total labor force) in Brazil in 2004 to that in 2007?
Offer a terse response. 0.99. What is the ratio of the Female Labor Force(as % of total labor force) of Cote d'Ivoire in 2004 to that in 2007?
Your answer should be very brief. 0.98. What is the ratio of the Female Labor Force(as % of total labor force) of El Salvador in 2004 to that in 2007?
Offer a very short reply. 0.98. What is the ratio of the Female Labor Force(as % of total labor force) of Brazil in 2004 to that in 2008?
Give a very brief answer. 0.99. What is the ratio of the Female Labor Force(as % of total labor force) of Cote d'Ivoire in 2004 to that in 2008?
Provide a short and direct response. 0.97. What is the ratio of the Female Labor Force(as % of total labor force) of El Salvador in 2004 to that in 2008?
Offer a terse response. 0.98. What is the ratio of the Female Labor Force(as % of total labor force) of Brazil in 2004 to that in 2009?
Your answer should be compact. 0.98. What is the ratio of the Female Labor Force(as % of total labor force) in Cote d'Ivoire in 2004 to that in 2009?
Provide a short and direct response. 0.97. What is the ratio of the Female Labor Force(as % of total labor force) in El Salvador in 2004 to that in 2009?
Your answer should be compact. 0.97. What is the ratio of the Female Labor Force(as % of total labor force) of Brazil in 2004 to that in 2010?
Give a very brief answer. 0.98. What is the ratio of the Female Labor Force(as % of total labor force) in Cote d'Ivoire in 2004 to that in 2010?
Offer a very short reply. 0.96. What is the ratio of the Female Labor Force(as % of total labor force) of El Salvador in 2004 to that in 2010?
Keep it short and to the point. 0.96. What is the ratio of the Female Labor Force(as % of total labor force) of Brazil in 2004 to that in 2011?
Your answer should be very brief. 0.97. What is the ratio of the Female Labor Force(as % of total labor force) in Cote d'Ivoire in 2004 to that in 2011?
Ensure brevity in your answer.  0.96. What is the ratio of the Female Labor Force(as % of total labor force) of El Salvador in 2004 to that in 2011?
Offer a very short reply. 0.96. What is the ratio of the Female Labor Force(as % of total labor force) of El Salvador in 2005 to that in 2006?
Provide a succinct answer. 0.99. What is the ratio of the Female Labor Force(as % of total labor force) in Brazil in 2005 to that in 2007?
Your response must be concise. 1. What is the ratio of the Female Labor Force(as % of total labor force) in El Salvador in 2005 to that in 2008?
Your answer should be very brief. 0.99. What is the ratio of the Female Labor Force(as % of total labor force) in Brazil in 2005 to that in 2009?
Ensure brevity in your answer.  0.99. What is the ratio of the Female Labor Force(as % of total labor force) of Cote d'Ivoire in 2005 to that in 2009?
Give a very brief answer. 0.97. What is the ratio of the Female Labor Force(as % of total labor force) of El Salvador in 2005 to that in 2009?
Make the answer very short. 0.98. What is the ratio of the Female Labor Force(as % of total labor force) in Brazil in 2005 to that in 2010?
Your answer should be very brief. 0.99. What is the ratio of the Female Labor Force(as % of total labor force) of Cote d'Ivoire in 2005 to that in 2010?
Make the answer very short. 0.97. What is the ratio of the Female Labor Force(as % of total labor force) in El Salvador in 2005 to that in 2010?
Offer a very short reply. 0.97. What is the ratio of the Female Labor Force(as % of total labor force) of Brazil in 2005 to that in 2011?
Offer a very short reply. 0.98. What is the ratio of the Female Labor Force(as % of total labor force) of Cote d'Ivoire in 2005 to that in 2011?
Make the answer very short. 0.96. What is the ratio of the Female Labor Force(as % of total labor force) in El Salvador in 2005 to that in 2011?
Ensure brevity in your answer.  0.97. What is the ratio of the Female Labor Force(as % of total labor force) in Cote d'Ivoire in 2006 to that in 2008?
Make the answer very short. 0.99. What is the ratio of the Female Labor Force(as % of total labor force) of El Salvador in 2006 to that in 2008?
Offer a terse response. 1. What is the ratio of the Female Labor Force(as % of total labor force) of Brazil in 2006 to that in 2009?
Provide a short and direct response. 0.99. What is the ratio of the Female Labor Force(as % of total labor force) of Cote d'Ivoire in 2006 to that in 2009?
Provide a succinct answer. 0.98. What is the ratio of the Female Labor Force(as % of total labor force) of El Salvador in 2006 to that in 2009?
Provide a short and direct response. 0.99. What is the ratio of the Female Labor Force(as % of total labor force) of Cote d'Ivoire in 2006 to that in 2010?
Your response must be concise. 0.98. What is the ratio of the Female Labor Force(as % of total labor force) of El Salvador in 2006 to that in 2010?
Ensure brevity in your answer.  0.98. What is the ratio of the Female Labor Force(as % of total labor force) of Brazil in 2006 to that in 2011?
Make the answer very short. 0.99. What is the ratio of the Female Labor Force(as % of total labor force) in Cote d'Ivoire in 2006 to that in 2011?
Ensure brevity in your answer.  0.97. What is the ratio of the Female Labor Force(as % of total labor force) of El Salvador in 2006 to that in 2011?
Your answer should be compact. 0.97. What is the ratio of the Female Labor Force(as % of total labor force) of Brazil in 2007 to that in 2008?
Your response must be concise. 1. What is the ratio of the Female Labor Force(as % of total labor force) in Cote d'Ivoire in 2007 to that in 2009?
Offer a very short reply. 0.99. What is the ratio of the Female Labor Force(as % of total labor force) of El Salvador in 2007 to that in 2009?
Your response must be concise. 0.99. What is the ratio of the Female Labor Force(as % of total labor force) of Cote d'Ivoire in 2007 to that in 2010?
Offer a terse response. 0.98. What is the ratio of the Female Labor Force(as % of total labor force) in El Salvador in 2007 to that in 2010?
Ensure brevity in your answer.  0.98. What is the ratio of the Female Labor Force(as % of total labor force) of Brazil in 2007 to that in 2011?
Ensure brevity in your answer.  0.99. What is the ratio of the Female Labor Force(as % of total labor force) of Cote d'Ivoire in 2007 to that in 2011?
Provide a short and direct response. 0.98. What is the ratio of the Female Labor Force(as % of total labor force) in El Salvador in 2007 to that in 2011?
Your answer should be very brief. 0.98. What is the ratio of the Female Labor Force(as % of total labor force) of Cote d'Ivoire in 2008 to that in 2009?
Offer a terse response. 0.99. What is the ratio of the Female Labor Force(as % of total labor force) in Brazil in 2008 to that in 2010?
Your answer should be compact. 0.99. What is the ratio of the Female Labor Force(as % of total labor force) of El Salvador in 2008 to that in 2010?
Ensure brevity in your answer.  0.98. What is the ratio of the Female Labor Force(as % of total labor force) of Brazil in 2008 to that in 2011?
Keep it short and to the point. 0.99. What is the ratio of the Female Labor Force(as % of total labor force) of Cote d'Ivoire in 2008 to that in 2011?
Your response must be concise. 0.98. What is the ratio of the Female Labor Force(as % of total labor force) in El Salvador in 2008 to that in 2011?
Offer a very short reply. 0.98. What is the ratio of the Female Labor Force(as % of total labor force) of Brazil in 2009 to that in 2010?
Ensure brevity in your answer.  0.99. What is the ratio of the Female Labor Force(as % of total labor force) of Cote d'Ivoire in 2009 to that in 2010?
Your response must be concise. 0.99. What is the ratio of the Female Labor Force(as % of total labor force) in El Salvador in 2009 to that in 2010?
Ensure brevity in your answer.  0.99. What is the ratio of the Female Labor Force(as % of total labor force) in Brazil in 2009 to that in 2011?
Your response must be concise. 0.99. What is the ratio of the Female Labor Force(as % of total labor force) of Cote d'Ivoire in 2009 to that in 2011?
Keep it short and to the point. 0.99. What is the ratio of the Female Labor Force(as % of total labor force) of El Salvador in 2009 to that in 2011?
Your answer should be very brief. 0.99. What is the ratio of the Female Labor Force(as % of total labor force) of El Salvador in 2010 to that in 2011?
Provide a succinct answer. 0.99. What is the difference between the highest and the second highest Female Labor Force(as % of total labor force) in Brazil?
Your answer should be very brief. 0.14. What is the difference between the highest and the second highest Female Labor Force(as % of total labor force) in Cote d'Ivoire?
Your answer should be compact. 0.2. What is the difference between the highest and the second highest Female Labor Force(as % of total labor force) in El Salvador?
Offer a very short reply. 0.21. What is the difference between the highest and the lowest Female Labor Force(as % of total labor force) in Brazil?
Offer a terse response. 1.15. What is the difference between the highest and the lowest Female Labor Force(as % of total labor force) in Cote d'Ivoire?
Keep it short and to the point. 1.66. What is the difference between the highest and the lowest Female Labor Force(as % of total labor force) in El Salvador?
Offer a very short reply. 1.81. 